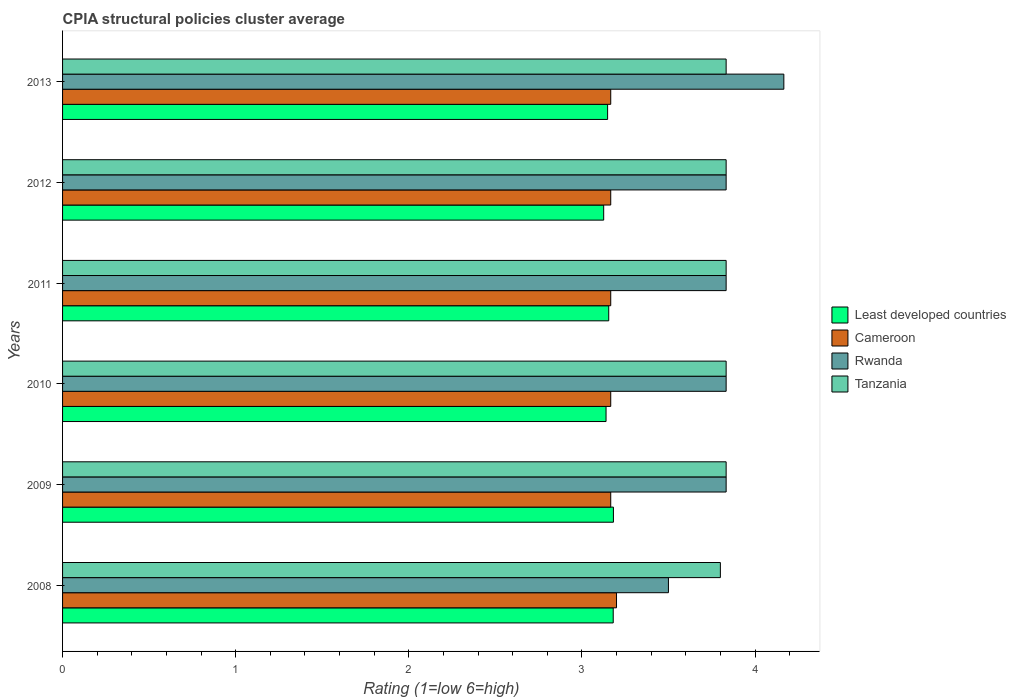How many groups of bars are there?
Provide a succinct answer. 6. Are the number of bars per tick equal to the number of legend labels?
Offer a terse response. Yes. How many bars are there on the 1st tick from the bottom?
Your response must be concise. 4. What is the label of the 6th group of bars from the top?
Make the answer very short. 2008. In how many cases, is the number of bars for a given year not equal to the number of legend labels?
Make the answer very short. 0. What is the CPIA rating in Cameroon in 2011?
Offer a terse response. 3.17. Across all years, what is the maximum CPIA rating in Rwanda?
Ensure brevity in your answer.  4.17. Across all years, what is the minimum CPIA rating in Least developed countries?
Your answer should be very brief. 3.13. In which year was the CPIA rating in Least developed countries maximum?
Give a very brief answer. 2009. What is the total CPIA rating in Tanzania in the graph?
Keep it short and to the point. 22.97. What is the difference between the CPIA rating in Cameroon in 2010 and that in 2013?
Keep it short and to the point. 0. What is the difference between the CPIA rating in Least developed countries in 2008 and the CPIA rating in Cameroon in 2013?
Ensure brevity in your answer.  0.01. What is the average CPIA rating in Cameroon per year?
Provide a succinct answer. 3.17. In the year 2008, what is the difference between the CPIA rating in Least developed countries and CPIA rating in Tanzania?
Ensure brevity in your answer.  -0.62. What is the ratio of the CPIA rating in Tanzania in 2008 to that in 2011?
Keep it short and to the point. 0.99. Is the difference between the CPIA rating in Least developed countries in 2011 and 2012 greater than the difference between the CPIA rating in Tanzania in 2011 and 2012?
Offer a very short reply. Yes. What is the difference between the highest and the second highest CPIA rating in Least developed countries?
Keep it short and to the point. 0. What is the difference between the highest and the lowest CPIA rating in Least developed countries?
Offer a very short reply. 0.06. Is the sum of the CPIA rating in Least developed countries in 2010 and 2011 greater than the maximum CPIA rating in Rwanda across all years?
Provide a short and direct response. Yes. What does the 1st bar from the top in 2009 represents?
Offer a very short reply. Tanzania. What does the 2nd bar from the bottom in 2009 represents?
Your response must be concise. Cameroon. How many bars are there?
Your answer should be compact. 24. What is the difference between two consecutive major ticks on the X-axis?
Ensure brevity in your answer.  1. Does the graph contain any zero values?
Provide a succinct answer. No. How many legend labels are there?
Provide a short and direct response. 4. How are the legend labels stacked?
Provide a succinct answer. Vertical. What is the title of the graph?
Offer a very short reply. CPIA structural policies cluster average. What is the label or title of the X-axis?
Offer a terse response. Rating (1=low 6=high). What is the Rating (1=low 6=high) in Least developed countries in 2008?
Offer a very short reply. 3.18. What is the Rating (1=low 6=high) of Cameroon in 2008?
Your answer should be very brief. 3.2. What is the Rating (1=low 6=high) in Least developed countries in 2009?
Provide a succinct answer. 3.18. What is the Rating (1=low 6=high) in Cameroon in 2009?
Provide a short and direct response. 3.17. What is the Rating (1=low 6=high) in Rwanda in 2009?
Your answer should be compact. 3.83. What is the Rating (1=low 6=high) of Tanzania in 2009?
Give a very brief answer. 3.83. What is the Rating (1=low 6=high) of Least developed countries in 2010?
Offer a terse response. 3.14. What is the Rating (1=low 6=high) in Cameroon in 2010?
Ensure brevity in your answer.  3.17. What is the Rating (1=low 6=high) in Rwanda in 2010?
Offer a very short reply. 3.83. What is the Rating (1=low 6=high) of Tanzania in 2010?
Make the answer very short. 3.83. What is the Rating (1=low 6=high) in Least developed countries in 2011?
Make the answer very short. 3.16. What is the Rating (1=low 6=high) of Cameroon in 2011?
Give a very brief answer. 3.17. What is the Rating (1=low 6=high) in Rwanda in 2011?
Offer a terse response. 3.83. What is the Rating (1=low 6=high) of Tanzania in 2011?
Your answer should be compact. 3.83. What is the Rating (1=low 6=high) of Least developed countries in 2012?
Ensure brevity in your answer.  3.13. What is the Rating (1=low 6=high) in Cameroon in 2012?
Make the answer very short. 3.17. What is the Rating (1=low 6=high) in Rwanda in 2012?
Your answer should be compact. 3.83. What is the Rating (1=low 6=high) of Tanzania in 2012?
Make the answer very short. 3.83. What is the Rating (1=low 6=high) in Least developed countries in 2013?
Make the answer very short. 3.15. What is the Rating (1=low 6=high) in Cameroon in 2013?
Offer a very short reply. 3.17. What is the Rating (1=low 6=high) in Rwanda in 2013?
Give a very brief answer. 4.17. What is the Rating (1=low 6=high) of Tanzania in 2013?
Give a very brief answer. 3.83. Across all years, what is the maximum Rating (1=low 6=high) of Least developed countries?
Ensure brevity in your answer.  3.18. Across all years, what is the maximum Rating (1=low 6=high) in Cameroon?
Ensure brevity in your answer.  3.2. Across all years, what is the maximum Rating (1=low 6=high) in Rwanda?
Give a very brief answer. 4.17. Across all years, what is the maximum Rating (1=low 6=high) in Tanzania?
Ensure brevity in your answer.  3.83. Across all years, what is the minimum Rating (1=low 6=high) in Least developed countries?
Make the answer very short. 3.13. Across all years, what is the minimum Rating (1=low 6=high) of Cameroon?
Keep it short and to the point. 3.17. Across all years, what is the minimum Rating (1=low 6=high) in Rwanda?
Keep it short and to the point. 3.5. Across all years, what is the minimum Rating (1=low 6=high) in Tanzania?
Provide a succinct answer. 3.8. What is the total Rating (1=low 6=high) of Least developed countries in the graph?
Offer a terse response. 18.93. What is the total Rating (1=low 6=high) of Cameroon in the graph?
Keep it short and to the point. 19.03. What is the total Rating (1=low 6=high) of Tanzania in the graph?
Make the answer very short. 22.97. What is the difference between the Rating (1=low 6=high) in Least developed countries in 2008 and that in 2009?
Make the answer very short. -0. What is the difference between the Rating (1=low 6=high) in Tanzania in 2008 and that in 2009?
Keep it short and to the point. -0.03. What is the difference between the Rating (1=low 6=high) of Least developed countries in 2008 and that in 2010?
Your answer should be very brief. 0.04. What is the difference between the Rating (1=low 6=high) of Cameroon in 2008 and that in 2010?
Make the answer very short. 0.03. What is the difference between the Rating (1=low 6=high) in Tanzania in 2008 and that in 2010?
Ensure brevity in your answer.  -0.03. What is the difference between the Rating (1=low 6=high) of Least developed countries in 2008 and that in 2011?
Your answer should be compact. 0.03. What is the difference between the Rating (1=low 6=high) of Cameroon in 2008 and that in 2011?
Your answer should be compact. 0.03. What is the difference between the Rating (1=low 6=high) in Tanzania in 2008 and that in 2011?
Your answer should be very brief. -0.03. What is the difference between the Rating (1=low 6=high) in Least developed countries in 2008 and that in 2012?
Your answer should be compact. 0.06. What is the difference between the Rating (1=low 6=high) in Cameroon in 2008 and that in 2012?
Make the answer very short. 0.03. What is the difference between the Rating (1=low 6=high) of Tanzania in 2008 and that in 2012?
Your answer should be compact. -0.03. What is the difference between the Rating (1=low 6=high) of Least developed countries in 2008 and that in 2013?
Offer a terse response. 0.03. What is the difference between the Rating (1=low 6=high) in Cameroon in 2008 and that in 2013?
Provide a succinct answer. 0.03. What is the difference between the Rating (1=low 6=high) of Rwanda in 2008 and that in 2013?
Keep it short and to the point. -0.67. What is the difference between the Rating (1=low 6=high) in Tanzania in 2008 and that in 2013?
Make the answer very short. -0.03. What is the difference between the Rating (1=low 6=high) of Least developed countries in 2009 and that in 2010?
Your answer should be compact. 0.04. What is the difference between the Rating (1=low 6=high) in Rwanda in 2009 and that in 2010?
Make the answer very short. 0. What is the difference between the Rating (1=low 6=high) in Least developed countries in 2009 and that in 2011?
Your answer should be compact. 0.03. What is the difference between the Rating (1=low 6=high) of Cameroon in 2009 and that in 2011?
Your answer should be very brief. 0. What is the difference between the Rating (1=low 6=high) of Rwanda in 2009 and that in 2011?
Offer a very short reply. 0. What is the difference between the Rating (1=low 6=high) in Tanzania in 2009 and that in 2011?
Ensure brevity in your answer.  0. What is the difference between the Rating (1=low 6=high) in Least developed countries in 2009 and that in 2012?
Ensure brevity in your answer.  0.06. What is the difference between the Rating (1=low 6=high) of Cameroon in 2009 and that in 2012?
Offer a terse response. 0. What is the difference between the Rating (1=low 6=high) of Rwanda in 2009 and that in 2012?
Ensure brevity in your answer.  0. What is the difference between the Rating (1=low 6=high) in Least developed countries in 2009 and that in 2013?
Keep it short and to the point. 0.03. What is the difference between the Rating (1=low 6=high) in Cameroon in 2009 and that in 2013?
Offer a very short reply. 0. What is the difference between the Rating (1=low 6=high) in Rwanda in 2009 and that in 2013?
Offer a very short reply. -0.33. What is the difference between the Rating (1=low 6=high) in Tanzania in 2009 and that in 2013?
Give a very brief answer. 0. What is the difference between the Rating (1=low 6=high) of Least developed countries in 2010 and that in 2011?
Your answer should be compact. -0.02. What is the difference between the Rating (1=low 6=high) in Cameroon in 2010 and that in 2011?
Ensure brevity in your answer.  0. What is the difference between the Rating (1=low 6=high) in Least developed countries in 2010 and that in 2012?
Make the answer very short. 0.01. What is the difference between the Rating (1=low 6=high) in Least developed countries in 2010 and that in 2013?
Keep it short and to the point. -0.01. What is the difference between the Rating (1=low 6=high) in Tanzania in 2010 and that in 2013?
Your answer should be very brief. 0. What is the difference between the Rating (1=low 6=high) of Least developed countries in 2011 and that in 2012?
Your response must be concise. 0.03. What is the difference between the Rating (1=low 6=high) of Cameroon in 2011 and that in 2012?
Your response must be concise. 0. What is the difference between the Rating (1=low 6=high) of Tanzania in 2011 and that in 2012?
Your answer should be very brief. 0. What is the difference between the Rating (1=low 6=high) of Least developed countries in 2011 and that in 2013?
Make the answer very short. 0.01. What is the difference between the Rating (1=low 6=high) of Least developed countries in 2012 and that in 2013?
Ensure brevity in your answer.  -0.02. What is the difference between the Rating (1=low 6=high) of Cameroon in 2012 and that in 2013?
Your answer should be compact. 0. What is the difference between the Rating (1=low 6=high) in Rwanda in 2012 and that in 2013?
Ensure brevity in your answer.  -0.33. What is the difference between the Rating (1=low 6=high) in Least developed countries in 2008 and the Rating (1=low 6=high) in Cameroon in 2009?
Your answer should be very brief. 0.01. What is the difference between the Rating (1=low 6=high) of Least developed countries in 2008 and the Rating (1=low 6=high) of Rwanda in 2009?
Give a very brief answer. -0.65. What is the difference between the Rating (1=low 6=high) of Least developed countries in 2008 and the Rating (1=low 6=high) of Tanzania in 2009?
Your answer should be compact. -0.65. What is the difference between the Rating (1=low 6=high) in Cameroon in 2008 and the Rating (1=low 6=high) in Rwanda in 2009?
Keep it short and to the point. -0.63. What is the difference between the Rating (1=low 6=high) in Cameroon in 2008 and the Rating (1=low 6=high) in Tanzania in 2009?
Your answer should be compact. -0.63. What is the difference between the Rating (1=low 6=high) of Least developed countries in 2008 and the Rating (1=low 6=high) of Cameroon in 2010?
Provide a succinct answer. 0.01. What is the difference between the Rating (1=low 6=high) in Least developed countries in 2008 and the Rating (1=low 6=high) in Rwanda in 2010?
Provide a short and direct response. -0.65. What is the difference between the Rating (1=low 6=high) in Least developed countries in 2008 and the Rating (1=low 6=high) in Tanzania in 2010?
Your response must be concise. -0.65. What is the difference between the Rating (1=low 6=high) in Cameroon in 2008 and the Rating (1=low 6=high) in Rwanda in 2010?
Your response must be concise. -0.63. What is the difference between the Rating (1=low 6=high) in Cameroon in 2008 and the Rating (1=low 6=high) in Tanzania in 2010?
Give a very brief answer. -0.63. What is the difference between the Rating (1=low 6=high) of Least developed countries in 2008 and the Rating (1=low 6=high) of Cameroon in 2011?
Your response must be concise. 0.01. What is the difference between the Rating (1=low 6=high) in Least developed countries in 2008 and the Rating (1=low 6=high) in Rwanda in 2011?
Offer a very short reply. -0.65. What is the difference between the Rating (1=low 6=high) of Least developed countries in 2008 and the Rating (1=low 6=high) of Tanzania in 2011?
Provide a succinct answer. -0.65. What is the difference between the Rating (1=low 6=high) of Cameroon in 2008 and the Rating (1=low 6=high) of Rwanda in 2011?
Keep it short and to the point. -0.63. What is the difference between the Rating (1=low 6=high) in Cameroon in 2008 and the Rating (1=low 6=high) in Tanzania in 2011?
Offer a very short reply. -0.63. What is the difference between the Rating (1=low 6=high) in Least developed countries in 2008 and the Rating (1=low 6=high) in Cameroon in 2012?
Provide a succinct answer. 0.01. What is the difference between the Rating (1=low 6=high) of Least developed countries in 2008 and the Rating (1=low 6=high) of Rwanda in 2012?
Offer a very short reply. -0.65. What is the difference between the Rating (1=low 6=high) of Least developed countries in 2008 and the Rating (1=low 6=high) of Tanzania in 2012?
Keep it short and to the point. -0.65. What is the difference between the Rating (1=low 6=high) of Cameroon in 2008 and the Rating (1=low 6=high) of Rwanda in 2012?
Ensure brevity in your answer.  -0.63. What is the difference between the Rating (1=low 6=high) in Cameroon in 2008 and the Rating (1=low 6=high) in Tanzania in 2012?
Provide a short and direct response. -0.63. What is the difference between the Rating (1=low 6=high) of Rwanda in 2008 and the Rating (1=low 6=high) of Tanzania in 2012?
Give a very brief answer. -0.33. What is the difference between the Rating (1=low 6=high) in Least developed countries in 2008 and the Rating (1=low 6=high) in Cameroon in 2013?
Give a very brief answer. 0.01. What is the difference between the Rating (1=low 6=high) in Least developed countries in 2008 and the Rating (1=low 6=high) in Rwanda in 2013?
Give a very brief answer. -0.99. What is the difference between the Rating (1=low 6=high) in Least developed countries in 2008 and the Rating (1=low 6=high) in Tanzania in 2013?
Your answer should be compact. -0.65. What is the difference between the Rating (1=low 6=high) of Cameroon in 2008 and the Rating (1=low 6=high) of Rwanda in 2013?
Offer a terse response. -0.97. What is the difference between the Rating (1=low 6=high) of Cameroon in 2008 and the Rating (1=low 6=high) of Tanzania in 2013?
Your response must be concise. -0.63. What is the difference between the Rating (1=low 6=high) in Rwanda in 2008 and the Rating (1=low 6=high) in Tanzania in 2013?
Provide a succinct answer. -0.33. What is the difference between the Rating (1=low 6=high) in Least developed countries in 2009 and the Rating (1=low 6=high) in Cameroon in 2010?
Your answer should be very brief. 0.02. What is the difference between the Rating (1=low 6=high) of Least developed countries in 2009 and the Rating (1=low 6=high) of Rwanda in 2010?
Your answer should be compact. -0.65. What is the difference between the Rating (1=low 6=high) in Least developed countries in 2009 and the Rating (1=low 6=high) in Tanzania in 2010?
Your answer should be compact. -0.65. What is the difference between the Rating (1=low 6=high) of Least developed countries in 2009 and the Rating (1=low 6=high) of Cameroon in 2011?
Your answer should be compact. 0.02. What is the difference between the Rating (1=low 6=high) in Least developed countries in 2009 and the Rating (1=low 6=high) in Rwanda in 2011?
Provide a short and direct response. -0.65. What is the difference between the Rating (1=low 6=high) in Least developed countries in 2009 and the Rating (1=low 6=high) in Tanzania in 2011?
Your answer should be compact. -0.65. What is the difference between the Rating (1=low 6=high) of Rwanda in 2009 and the Rating (1=low 6=high) of Tanzania in 2011?
Your answer should be compact. 0. What is the difference between the Rating (1=low 6=high) in Least developed countries in 2009 and the Rating (1=low 6=high) in Cameroon in 2012?
Provide a short and direct response. 0.02. What is the difference between the Rating (1=low 6=high) of Least developed countries in 2009 and the Rating (1=low 6=high) of Rwanda in 2012?
Ensure brevity in your answer.  -0.65. What is the difference between the Rating (1=low 6=high) of Least developed countries in 2009 and the Rating (1=low 6=high) of Tanzania in 2012?
Offer a terse response. -0.65. What is the difference between the Rating (1=low 6=high) of Cameroon in 2009 and the Rating (1=low 6=high) of Rwanda in 2012?
Give a very brief answer. -0.67. What is the difference between the Rating (1=low 6=high) of Cameroon in 2009 and the Rating (1=low 6=high) of Tanzania in 2012?
Your response must be concise. -0.67. What is the difference between the Rating (1=low 6=high) in Least developed countries in 2009 and the Rating (1=low 6=high) in Cameroon in 2013?
Your answer should be very brief. 0.02. What is the difference between the Rating (1=low 6=high) in Least developed countries in 2009 and the Rating (1=low 6=high) in Rwanda in 2013?
Ensure brevity in your answer.  -0.98. What is the difference between the Rating (1=low 6=high) of Least developed countries in 2009 and the Rating (1=low 6=high) of Tanzania in 2013?
Ensure brevity in your answer.  -0.65. What is the difference between the Rating (1=low 6=high) of Cameroon in 2009 and the Rating (1=low 6=high) of Rwanda in 2013?
Your response must be concise. -1. What is the difference between the Rating (1=low 6=high) of Rwanda in 2009 and the Rating (1=low 6=high) of Tanzania in 2013?
Ensure brevity in your answer.  0. What is the difference between the Rating (1=low 6=high) in Least developed countries in 2010 and the Rating (1=low 6=high) in Cameroon in 2011?
Your answer should be very brief. -0.03. What is the difference between the Rating (1=low 6=high) in Least developed countries in 2010 and the Rating (1=low 6=high) in Rwanda in 2011?
Your response must be concise. -0.69. What is the difference between the Rating (1=low 6=high) of Least developed countries in 2010 and the Rating (1=low 6=high) of Tanzania in 2011?
Provide a short and direct response. -0.69. What is the difference between the Rating (1=low 6=high) of Rwanda in 2010 and the Rating (1=low 6=high) of Tanzania in 2011?
Give a very brief answer. 0. What is the difference between the Rating (1=low 6=high) of Least developed countries in 2010 and the Rating (1=low 6=high) of Cameroon in 2012?
Your answer should be very brief. -0.03. What is the difference between the Rating (1=low 6=high) in Least developed countries in 2010 and the Rating (1=low 6=high) in Rwanda in 2012?
Make the answer very short. -0.69. What is the difference between the Rating (1=low 6=high) in Least developed countries in 2010 and the Rating (1=low 6=high) in Tanzania in 2012?
Your answer should be compact. -0.69. What is the difference between the Rating (1=low 6=high) of Cameroon in 2010 and the Rating (1=low 6=high) of Rwanda in 2012?
Provide a short and direct response. -0.67. What is the difference between the Rating (1=low 6=high) in Least developed countries in 2010 and the Rating (1=low 6=high) in Cameroon in 2013?
Offer a terse response. -0.03. What is the difference between the Rating (1=low 6=high) of Least developed countries in 2010 and the Rating (1=low 6=high) of Rwanda in 2013?
Your answer should be very brief. -1.03. What is the difference between the Rating (1=low 6=high) in Least developed countries in 2010 and the Rating (1=low 6=high) in Tanzania in 2013?
Your answer should be very brief. -0.69. What is the difference between the Rating (1=low 6=high) in Cameroon in 2010 and the Rating (1=low 6=high) in Rwanda in 2013?
Make the answer very short. -1. What is the difference between the Rating (1=low 6=high) in Rwanda in 2010 and the Rating (1=low 6=high) in Tanzania in 2013?
Offer a terse response. 0. What is the difference between the Rating (1=low 6=high) in Least developed countries in 2011 and the Rating (1=low 6=high) in Cameroon in 2012?
Make the answer very short. -0.01. What is the difference between the Rating (1=low 6=high) of Least developed countries in 2011 and the Rating (1=low 6=high) of Rwanda in 2012?
Your response must be concise. -0.68. What is the difference between the Rating (1=low 6=high) of Least developed countries in 2011 and the Rating (1=low 6=high) of Tanzania in 2012?
Ensure brevity in your answer.  -0.68. What is the difference between the Rating (1=low 6=high) of Cameroon in 2011 and the Rating (1=low 6=high) of Rwanda in 2012?
Your answer should be compact. -0.67. What is the difference between the Rating (1=low 6=high) of Cameroon in 2011 and the Rating (1=low 6=high) of Tanzania in 2012?
Give a very brief answer. -0.67. What is the difference between the Rating (1=low 6=high) of Least developed countries in 2011 and the Rating (1=low 6=high) of Cameroon in 2013?
Provide a short and direct response. -0.01. What is the difference between the Rating (1=low 6=high) of Least developed countries in 2011 and the Rating (1=low 6=high) of Rwanda in 2013?
Offer a very short reply. -1.01. What is the difference between the Rating (1=low 6=high) of Least developed countries in 2011 and the Rating (1=low 6=high) of Tanzania in 2013?
Offer a very short reply. -0.68. What is the difference between the Rating (1=low 6=high) in Cameroon in 2011 and the Rating (1=low 6=high) in Rwanda in 2013?
Your answer should be very brief. -1. What is the difference between the Rating (1=low 6=high) of Least developed countries in 2012 and the Rating (1=low 6=high) of Cameroon in 2013?
Your response must be concise. -0.04. What is the difference between the Rating (1=low 6=high) of Least developed countries in 2012 and the Rating (1=low 6=high) of Rwanda in 2013?
Make the answer very short. -1.04. What is the difference between the Rating (1=low 6=high) in Least developed countries in 2012 and the Rating (1=low 6=high) in Tanzania in 2013?
Provide a succinct answer. -0.71. What is the difference between the Rating (1=low 6=high) in Cameroon in 2012 and the Rating (1=low 6=high) in Tanzania in 2013?
Offer a terse response. -0.67. What is the average Rating (1=low 6=high) in Least developed countries per year?
Your response must be concise. 3.16. What is the average Rating (1=low 6=high) of Cameroon per year?
Provide a succinct answer. 3.17. What is the average Rating (1=low 6=high) of Rwanda per year?
Ensure brevity in your answer.  3.83. What is the average Rating (1=low 6=high) of Tanzania per year?
Provide a short and direct response. 3.83. In the year 2008, what is the difference between the Rating (1=low 6=high) in Least developed countries and Rating (1=low 6=high) in Cameroon?
Give a very brief answer. -0.02. In the year 2008, what is the difference between the Rating (1=low 6=high) in Least developed countries and Rating (1=low 6=high) in Rwanda?
Ensure brevity in your answer.  -0.32. In the year 2008, what is the difference between the Rating (1=low 6=high) in Least developed countries and Rating (1=low 6=high) in Tanzania?
Your response must be concise. -0.62. In the year 2008, what is the difference between the Rating (1=low 6=high) in Cameroon and Rating (1=low 6=high) in Rwanda?
Offer a very short reply. -0.3. In the year 2009, what is the difference between the Rating (1=low 6=high) in Least developed countries and Rating (1=low 6=high) in Cameroon?
Offer a very short reply. 0.02. In the year 2009, what is the difference between the Rating (1=low 6=high) of Least developed countries and Rating (1=low 6=high) of Rwanda?
Your answer should be very brief. -0.65. In the year 2009, what is the difference between the Rating (1=low 6=high) of Least developed countries and Rating (1=low 6=high) of Tanzania?
Make the answer very short. -0.65. In the year 2009, what is the difference between the Rating (1=low 6=high) of Cameroon and Rating (1=low 6=high) of Rwanda?
Give a very brief answer. -0.67. In the year 2009, what is the difference between the Rating (1=low 6=high) in Cameroon and Rating (1=low 6=high) in Tanzania?
Provide a short and direct response. -0.67. In the year 2009, what is the difference between the Rating (1=low 6=high) in Rwanda and Rating (1=low 6=high) in Tanzania?
Offer a very short reply. 0. In the year 2010, what is the difference between the Rating (1=low 6=high) of Least developed countries and Rating (1=low 6=high) of Cameroon?
Offer a terse response. -0.03. In the year 2010, what is the difference between the Rating (1=low 6=high) of Least developed countries and Rating (1=low 6=high) of Rwanda?
Give a very brief answer. -0.69. In the year 2010, what is the difference between the Rating (1=low 6=high) in Least developed countries and Rating (1=low 6=high) in Tanzania?
Provide a short and direct response. -0.69. In the year 2010, what is the difference between the Rating (1=low 6=high) in Cameroon and Rating (1=low 6=high) in Rwanda?
Make the answer very short. -0.67. In the year 2010, what is the difference between the Rating (1=low 6=high) in Rwanda and Rating (1=low 6=high) in Tanzania?
Your answer should be compact. 0. In the year 2011, what is the difference between the Rating (1=low 6=high) in Least developed countries and Rating (1=low 6=high) in Cameroon?
Provide a succinct answer. -0.01. In the year 2011, what is the difference between the Rating (1=low 6=high) in Least developed countries and Rating (1=low 6=high) in Rwanda?
Ensure brevity in your answer.  -0.68. In the year 2011, what is the difference between the Rating (1=low 6=high) in Least developed countries and Rating (1=low 6=high) in Tanzania?
Make the answer very short. -0.68. In the year 2012, what is the difference between the Rating (1=low 6=high) of Least developed countries and Rating (1=low 6=high) of Cameroon?
Provide a succinct answer. -0.04. In the year 2012, what is the difference between the Rating (1=low 6=high) in Least developed countries and Rating (1=low 6=high) in Rwanda?
Offer a very short reply. -0.71. In the year 2012, what is the difference between the Rating (1=low 6=high) in Least developed countries and Rating (1=low 6=high) in Tanzania?
Your answer should be compact. -0.71. In the year 2012, what is the difference between the Rating (1=low 6=high) in Cameroon and Rating (1=low 6=high) in Rwanda?
Provide a short and direct response. -0.67. In the year 2012, what is the difference between the Rating (1=low 6=high) of Rwanda and Rating (1=low 6=high) of Tanzania?
Provide a succinct answer. 0. In the year 2013, what is the difference between the Rating (1=low 6=high) in Least developed countries and Rating (1=low 6=high) in Cameroon?
Keep it short and to the point. -0.02. In the year 2013, what is the difference between the Rating (1=low 6=high) in Least developed countries and Rating (1=low 6=high) in Rwanda?
Your answer should be compact. -1.02. In the year 2013, what is the difference between the Rating (1=low 6=high) of Least developed countries and Rating (1=low 6=high) of Tanzania?
Keep it short and to the point. -0.68. In the year 2013, what is the difference between the Rating (1=low 6=high) in Cameroon and Rating (1=low 6=high) in Rwanda?
Offer a very short reply. -1. In the year 2013, what is the difference between the Rating (1=low 6=high) in Cameroon and Rating (1=low 6=high) in Tanzania?
Offer a very short reply. -0.67. What is the ratio of the Rating (1=low 6=high) in Cameroon in 2008 to that in 2009?
Keep it short and to the point. 1.01. What is the ratio of the Rating (1=low 6=high) in Rwanda in 2008 to that in 2009?
Your answer should be compact. 0.91. What is the ratio of the Rating (1=low 6=high) of Least developed countries in 2008 to that in 2010?
Provide a succinct answer. 1.01. What is the ratio of the Rating (1=low 6=high) of Cameroon in 2008 to that in 2010?
Offer a very short reply. 1.01. What is the ratio of the Rating (1=low 6=high) in Rwanda in 2008 to that in 2010?
Provide a succinct answer. 0.91. What is the ratio of the Rating (1=low 6=high) of Tanzania in 2008 to that in 2010?
Provide a short and direct response. 0.99. What is the ratio of the Rating (1=low 6=high) of Least developed countries in 2008 to that in 2011?
Your answer should be very brief. 1.01. What is the ratio of the Rating (1=low 6=high) in Cameroon in 2008 to that in 2011?
Keep it short and to the point. 1.01. What is the ratio of the Rating (1=low 6=high) of Least developed countries in 2008 to that in 2012?
Ensure brevity in your answer.  1.02. What is the ratio of the Rating (1=low 6=high) of Cameroon in 2008 to that in 2012?
Offer a terse response. 1.01. What is the ratio of the Rating (1=low 6=high) of Least developed countries in 2008 to that in 2013?
Ensure brevity in your answer.  1.01. What is the ratio of the Rating (1=low 6=high) of Cameroon in 2008 to that in 2013?
Offer a very short reply. 1.01. What is the ratio of the Rating (1=low 6=high) of Rwanda in 2008 to that in 2013?
Your answer should be very brief. 0.84. What is the ratio of the Rating (1=low 6=high) of Tanzania in 2008 to that in 2013?
Give a very brief answer. 0.99. What is the ratio of the Rating (1=low 6=high) of Least developed countries in 2009 to that in 2010?
Offer a terse response. 1.01. What is the ratio of the Rating (1=low 6=high) of Cameroon in 2009 to that in 2010?
Provide a succinct answer. 1. What is the ratio of the Rating (1=low 6=high) of Rwanda in 2009 to that in 2010?
Ensure brevity in your answer.  1. What is the ratio of the Rating (1=low 6=high) of Least developed countries in 2009 to that in 2011?
Your response must be concise. 1.01. What is the ratio of the Rating (1=low 6=high) of Rwanda in 2009 to that in 2011?
Ensure brevity in your answer.  1. What is the ratio of the Rating (1=low 6=high) of Tanzania in 2009 to that in 2011?
Provide a succinct answer. 1. What is the ratio of the Rating (1=low 6=high) of Least developed countries in 2009 to that in 2012?
Ensure brevity in your answer.  1.02. What is the ratio of the Rating (1=low 6=high) in Rwanda in 2009 to that in 2012?
Your response must be concise. 1. What is the ratio of the Rating (1=low 6=high) in Least developed countries in 2009 to that in 2013?
Make the answer very short. 1.01. What is the ratio of the Rating (1=low 6=high) in Cameroon in 2009 to that in 2013?
Your response must be concise. 1. What is the ratio of the Rating (1=low 6=high) in Rwanda in 2010 to that in 2011?
Provide a succinct answer. 1. What is the ratio of the Rating (1=low 6=high) of Cameroon in 2010 to that in 2012?
Your answer should be compact. 1. What is the ratio of the Rating (1=low 6=high) of Rwanda in 2010 to that in 2012?
Ensure brevity in your answer.  1. What is the ratio of the Rating (1=low 6=high) in Tanzania in 2010 to that in 2012?
Make the answer very short. 1. What is the ratio of the Rating (1=low 6=high) of Least developed countries in 2010 to that in 2013?
Ensure brevity in your answer.  1. What is the ratio of the Rating (1=low 6=high) of Rwanda in 2010 to that in 2013?
Offer a very short reply. 0.92. What is the ratio of the Rating (1=low 6=high) of Least developed countries in 2011 to that in 2012?
Provide a succinct answer. 1.01. What is the ratio of the Rating (1=low 6=high) of Least developed countries in 2011 to that in 2013?
Give a very brief answer. 1. What is the ratio of the Rating (1=low 6=high) of Rwanda in 2011 to that in 2013?
Give a very brief answer. 0.92. What is the ratio of the Rating (1=low 6=high) in Cameroon in 2012 to that in 2013?
Make the answer very short. 1. What is the difference between the highest and the second highest Rating (1=low 6=high) of Least developed countries?
Provide a short and direct response. 0. What is the difference between the highest and the lowest Rating (1=low 6=high) in Least developed countries?
Ensure brevity in your answer.  0.06. What is the difference between the highest and the lowest Rating (1=low 6=high) in Cameroon?
Offer a very short reply. 0.03. What is the difference between the highest and the lowest Rating (1=low 6=high) in Rwanda?
Keep it short and to the point. 0.67. 